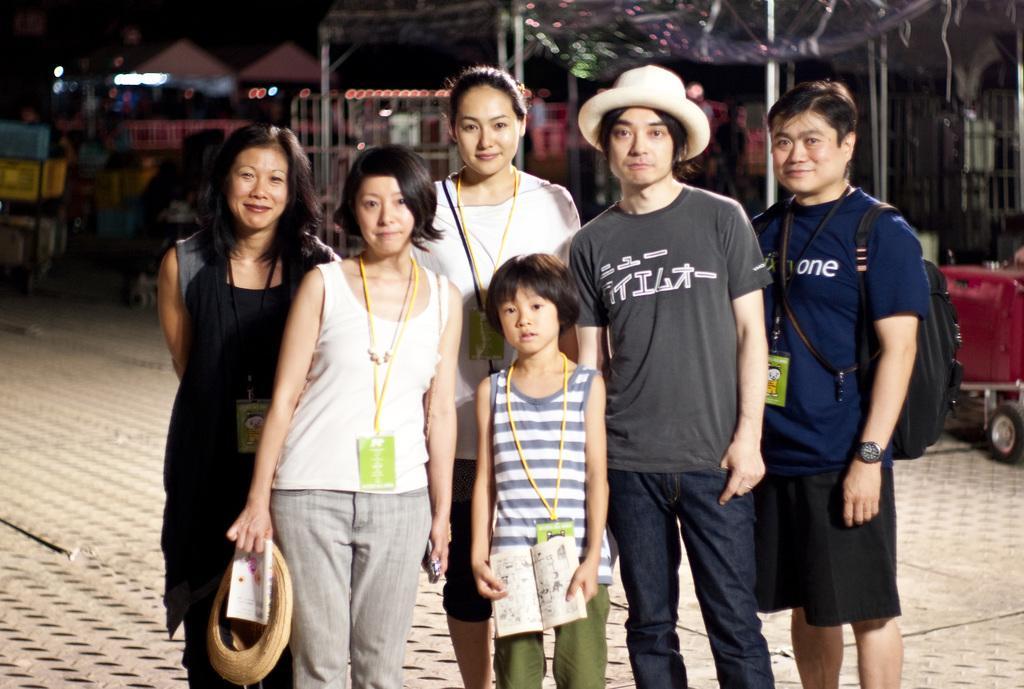How would you summarize this image in a sentence or two? In this image we can see some people standing on the ground and behind them we can see the lights. 